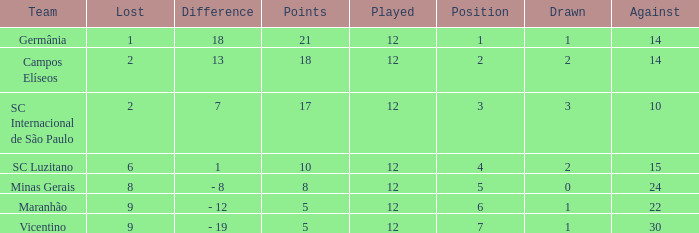What difference has a points greater than 10, and a drawn less than 2? 18.0. 